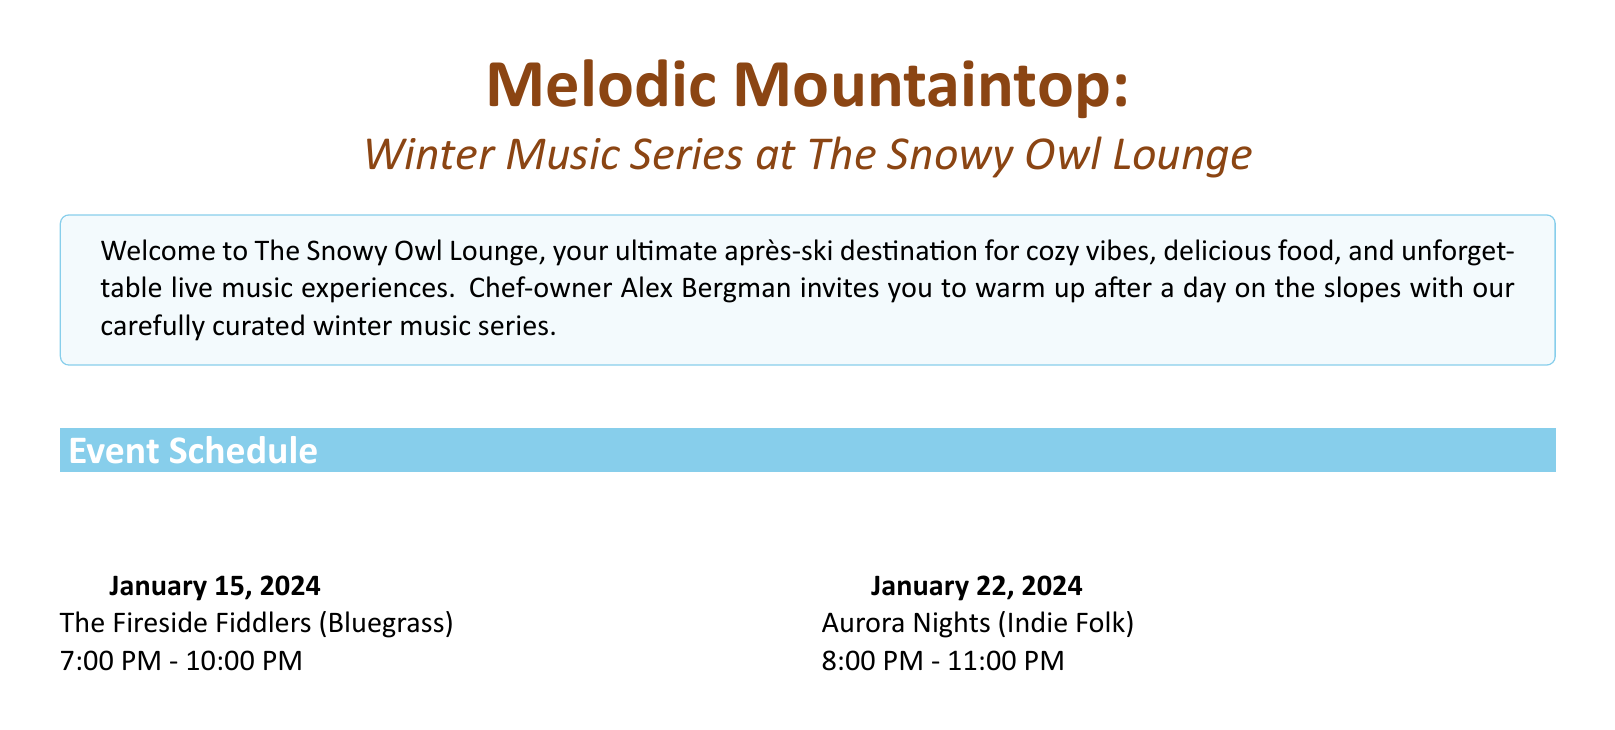What is the date of The Fireside Fiddlers' performance? The brochure lists the event schedule with specific dates and performers, showing The Fireside Fiddlers on January 15, 2024.
Answer: January 15, 2024 What genre does Aurora Nights perform? The genre descriptions are associated with each artist in the event schedule, indicating that Aurora Nights performs Indie Folk.
Answer: Indie Folk Who leads the Snowfall Jazz Quartet? The artist bios provide information about the members of each band, stating that Maria Frost leads the Snowfall Jazz Quartet.
Answer: Maria Frost What time does the performance by Alpine Echo start? The event schedule specifies the start and end times for each performance, showing that Alpine Echo starts at 7:30 PM.
Answer: 7:30 PM How long is the Ski & Sip Package offer valid? The special offers section mentions that the Ski & Sip Package offers a discount for visitors who present a same-day lift ticket.
Answer: Same-day What is the signature dish mentioned in the food highlights? The food and drink highlights section lists the Alpine Cheese Fondue as the signature dish for après-ski dining.
Answer: Alpine Cheese Fondue What is the primary theme used in the brochure's design? The introduction emphasizes the cozy après-ski atmosphere of The Snowy Owl Lounge, which reflects a rustic ski lodge theme throughout the brochure.
Answer: Rustic ski lodge Who are the members of Timber & Strings? The artist bios section lists the members of Timber & Strings as Liam Oak and Fiona Pine.
Answer: Liam Oak, Fiona Pine What is recommended for peak season weekends? The booking information advises that making reservations is highly recommended during peak season weekends.
Answer: Reservations 